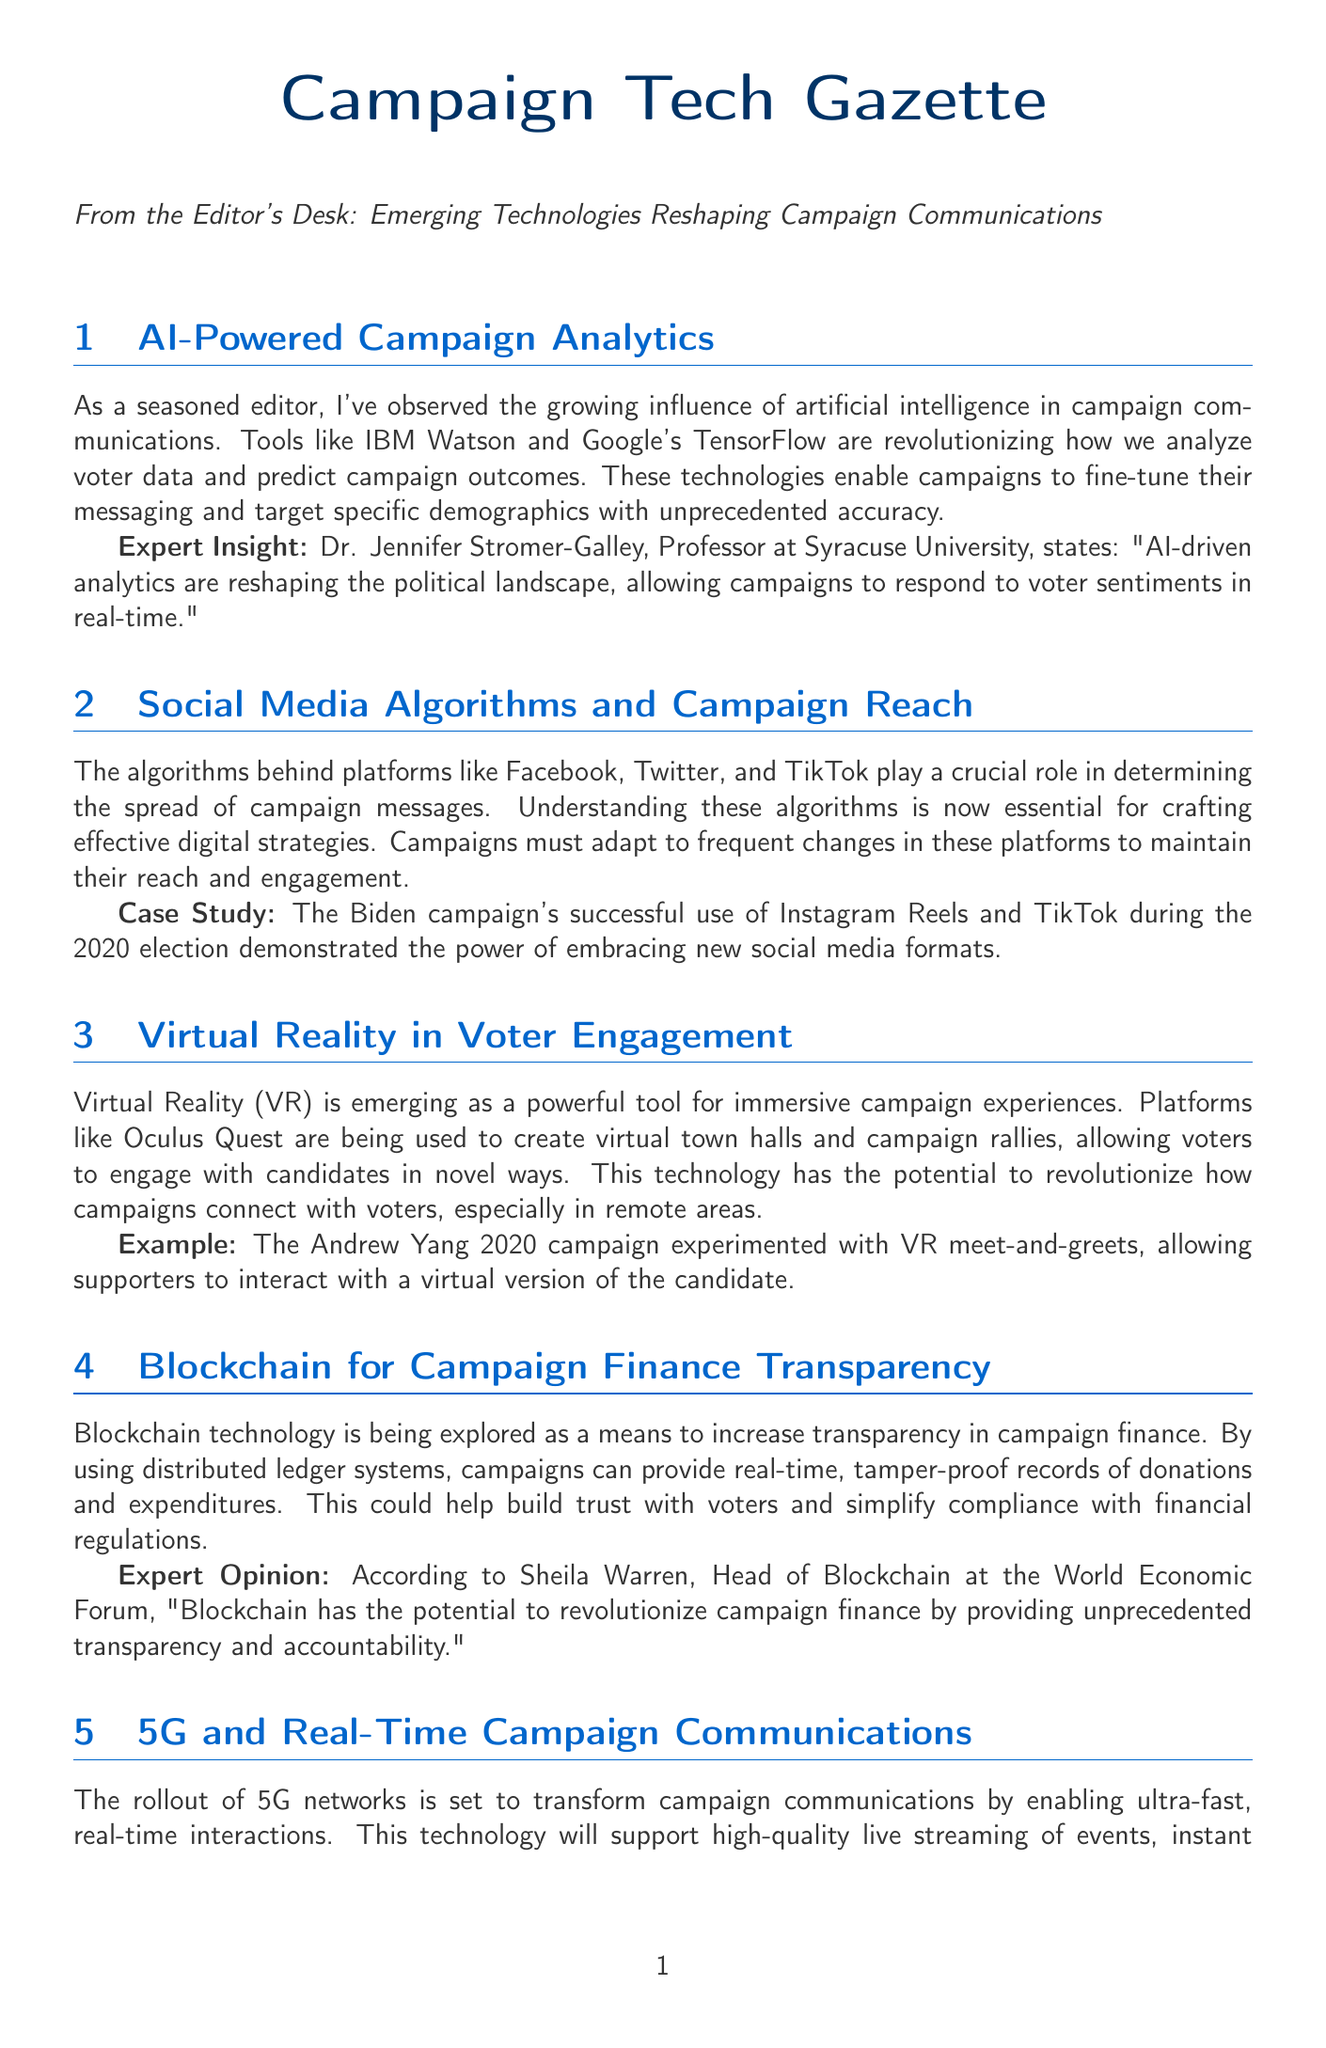What tools are mentioned in AI-Powered Campaign Analytics? The tools mentioned are IBM Watson and Google's TensorFlow.
Answer: IBM Watson and Google's TensorFlow What year did the Biden campaign utilize Instagram Reels and TikTok? The document states that the Biden campaign's successful use of these platforms was during the 2020 election.
Answer: 2020 What technology is being explored for campaign finance transparency? The document discusses the use of distributed ledger systems for this purpose.
Answer: Blockchain Who is the expert that commented on AI-driven analytics? Dr. Jennifer Stromer-Galley is mentioned as the expert providing insight.
Answer: Dr. Jennifer Stromer-Galley What is a key theme in technological adoption according to the editor's notes? One of the key themes is transparency in campaign communications.
Answer: Transparency What is the potential future role of 5G in campaigns? The document predicts that 5G will play a central role in campaign strategies by 2024.
Answer: Central role What immersive technology is mentioned for voter engagement? Virtual Reality (VR) is identified as the immersive technology for this purpose.
Answer: Virtual Reality (VR) What type of strategies must campaigns adapt to according to the document? Campaigns must adapt to the rapidly evolving digital landscapes.
Answer: Rapidly evolving digital landscapes 